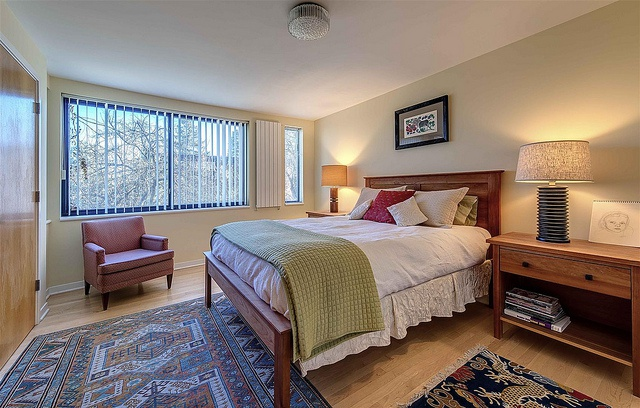Describe the objects in this image and their specific colors. I can see bed in darkgray, gray, and maroon tones, chair in darkgray, maroon, brown, and black tones, book in darkgray, black, and gray tones, book in darkgray, black, and gray tones, and book in darkgray, black, and gray tones in this image. 